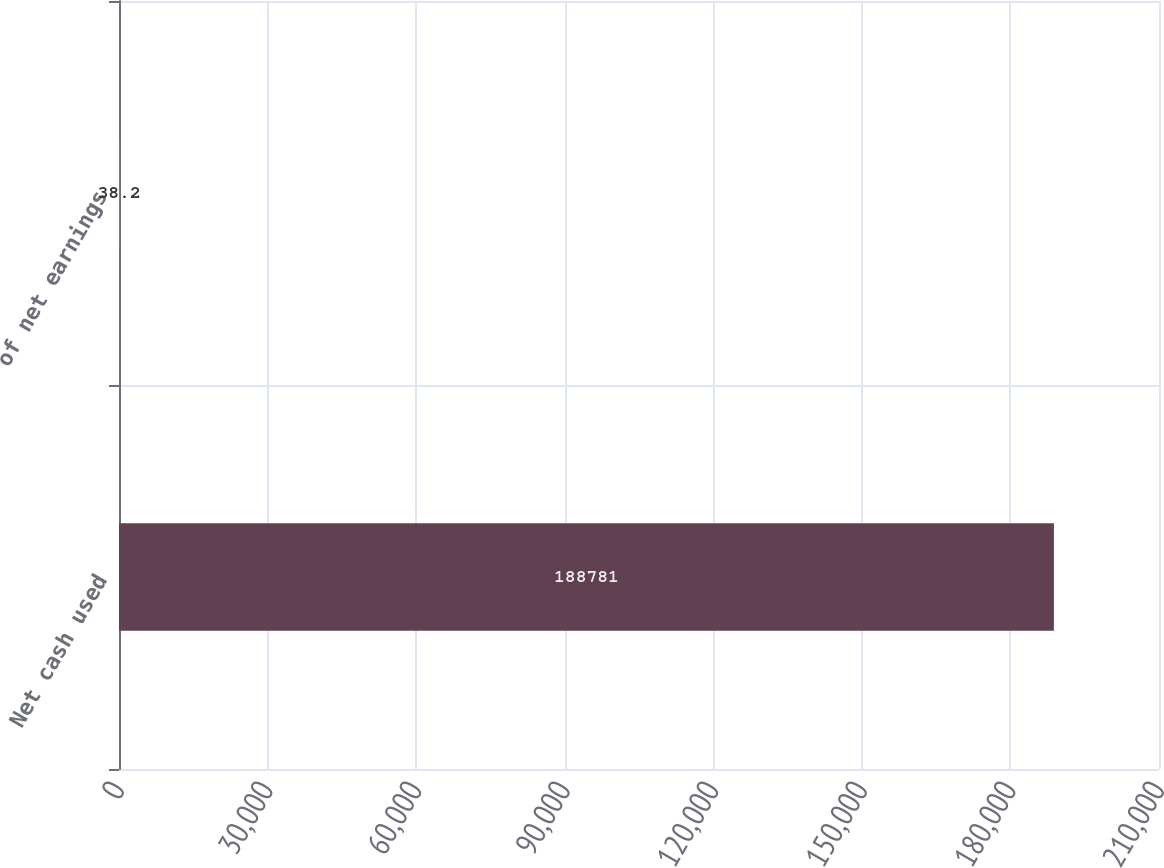<chart> <loc_0><loc_0><loc_500><loc_500><bar_chart><fcel>Net cash used<fcel>of net earnings<nl><fcel>188781<fcel>38.2<nl></chart> 